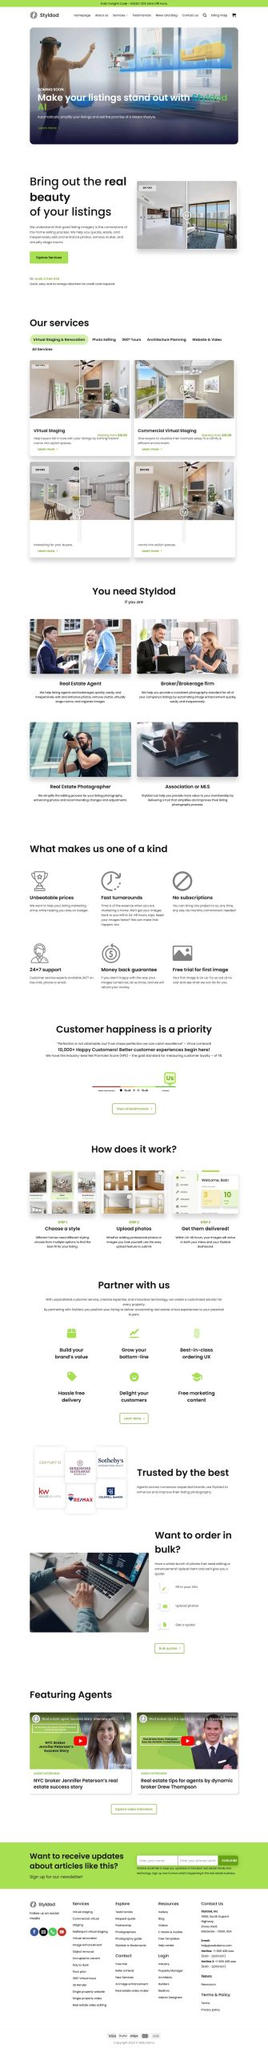Liệt kê 5 ngành nghề, lĩnh vực phù hợp với website này, phân cách các màu sắc bằng dấu phẩy. Chỉ trả về kết quả, phân cách bằng dấy phẩy
 Bất động sản, Nhiếp ảnh, Thiết kế nội thất, Tiếp thị, Công nghệ thông tin 